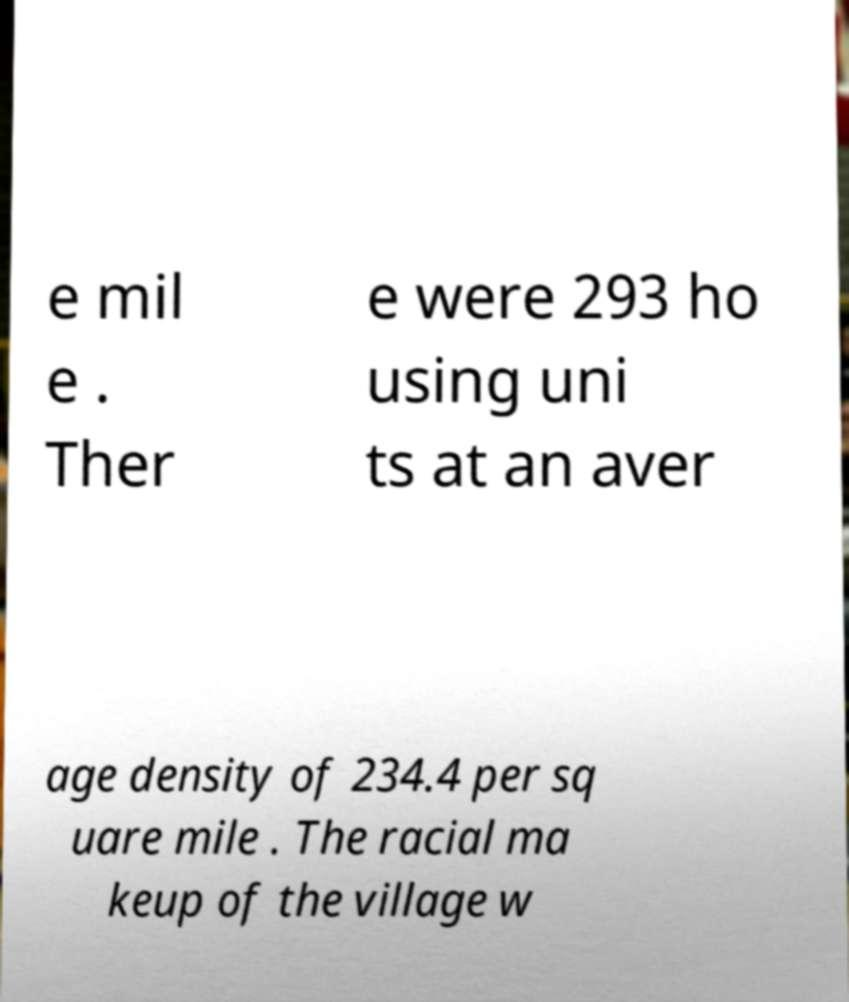Can you read and provide the text displayed in the image?This photo seems to have some interesting text. Can you extract and type it out for me? e mil e . Ther e were 293 ho using uni ts at an aver age density of 234.4 per sq uare mile . The racial ma keup of the village w 